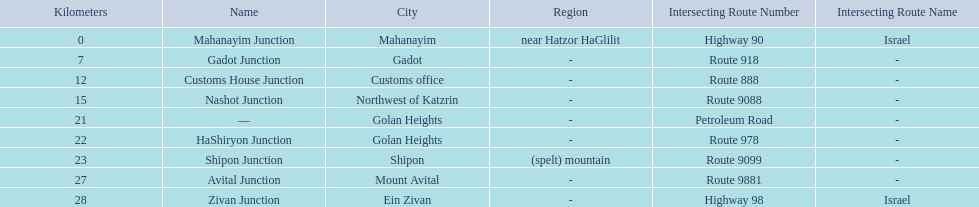Which junctions cross a route? Gadot Junction, Customs House Junction, Nashot Junction, HaShiryon Junction, Shipon Junction, Avital Junction. Which of these shares [art of its name with its locations name? Gadot Junction, Customs House Junction, Shipon Junction, Avital Junction. Which of them is not located in a locations named after a mountain? Gadot Junction, Customs House Junction. Which of these has the highest route number? Gadot Junction. 